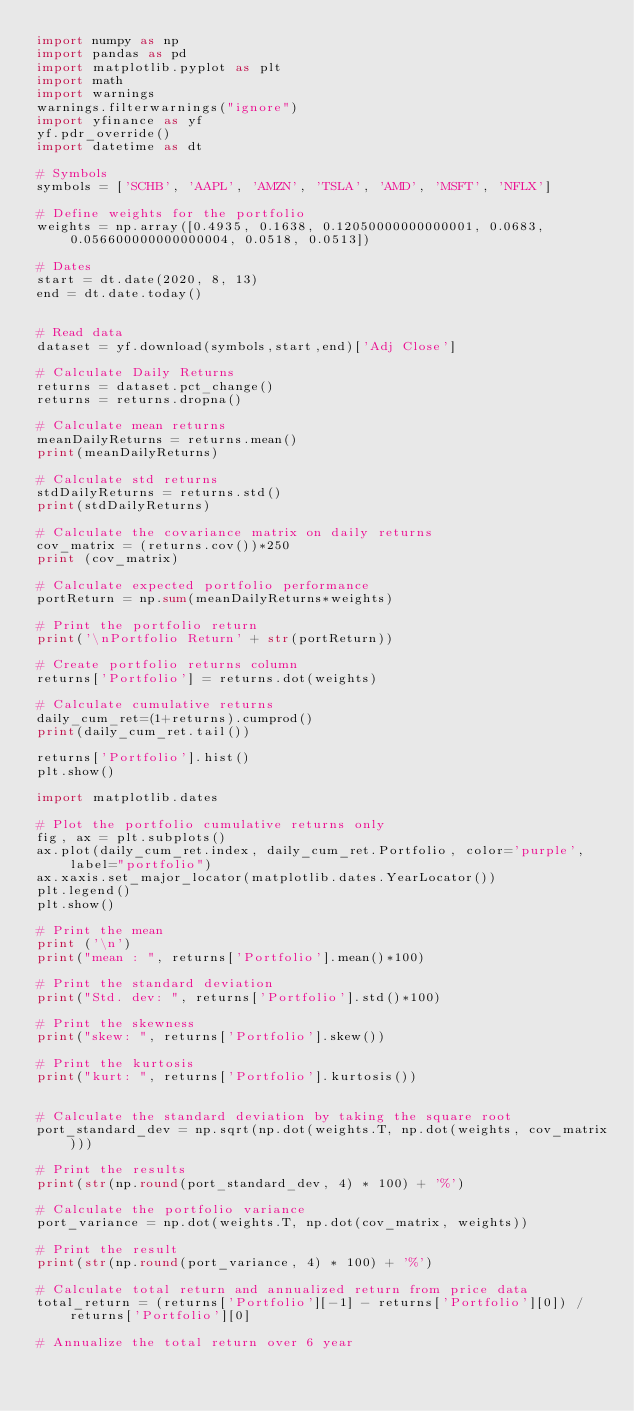<code> <loc_0><loc_0><loc_500><loc_500><_Python_>import numpy as np
import pandas as pd
import matplotlib.pyplot as plt
import math
import warnings
warnings.filterwarnings("ignore")
import yfinance as yf
yf.pdr_override()
import datetime as dt

# Symbols
symbols = ['SCHB', 'AAPL', 'AMZN', 'TSLA', 'AMD', 'MSFT', 'NFLX']

# Define weights for the portfolio
weights = np.array([0.4935, 0.1638, 0.12050000000000001, 0.0683, 0.056600000000000004, 0.0518, 0.0513])

# Dates
start = dt.date(2020, 8, 13)
end = dt.date.today()


# Read data 
dataset = yf.download(symbols,start,end)['Adj Close']

# Calculate Daily Returns
returns = dataset.pct_change()
returns = returns.dropna()

# Calculate mean returns
meanDailyReturns = returns.mean()
print(meanDailyReturns)

# Calculate std returns
stdDailyReturns = returns.std()
print(stdDailyReturns)

# Calculate the covariance matrix on daily returns
cov_matrix = (returns.cov())*250
print (cov_matrix)

# Calculate expected portfolio performance
portReturn = np.sum(meanDailyReturns*weights)

# Print the portfolio return
print('\nPortfolio Return' + str(portReturn))

# Create portfolio returns column
returns['Portfolio'] = returns.dot(weights)

# Calculate cumulative returns
daily_cum_ret=(1+returns).cumprod()
print(daily_cum_ret.tail())

returns['Portfolio'].hist()
plt.show()

import matplotlib.dates

# Plot the portfolio cumulative returns only
fig, ax = plt.subplots()
ax.plot(daily_cum_ret.index, daily_cum_ret.Portfolio, color='purple', label="portfolio")
ax.xaxis.set_major_locator(matplotlib.dates.YearLocator())
plt.legend()
plt.show()

# Print the mean
print ('\n')
print("mean : ", returns['Portfolio'].mean()*100)

# Print the standard deviation
print("Std. dev: ", returns['Portfolio'].std()*100)

# Print the skewness
print("skew: ", returns['Portfolio'].skew())

# Print the kurtosis
print("kurt: ", returns['Portfolio'].kurtosis())


# Calculate the standard deviation by taking the square root
port_standard_dev = np.sqrt(np.dot(weights.T, np.dot(weights, cov_matrix)))

# Print the results 
print(str(np.round(port_standard_dev, 4) * 100) + '%')

# Calculate the portfolio variance
port_variance = np.dot(weights.T, np.dot(cov_matrix, weights))

# Print the result
print(str(np.round(port_variance, 4) * 100) + '%')

# Calculate total return and annualized return from price data 
total_return = (returns['Portfolio'][-1] - returns['Portfolio'][0]) / returns['Portfolio'][0]

# Annualize the total return over 6 year </code> 